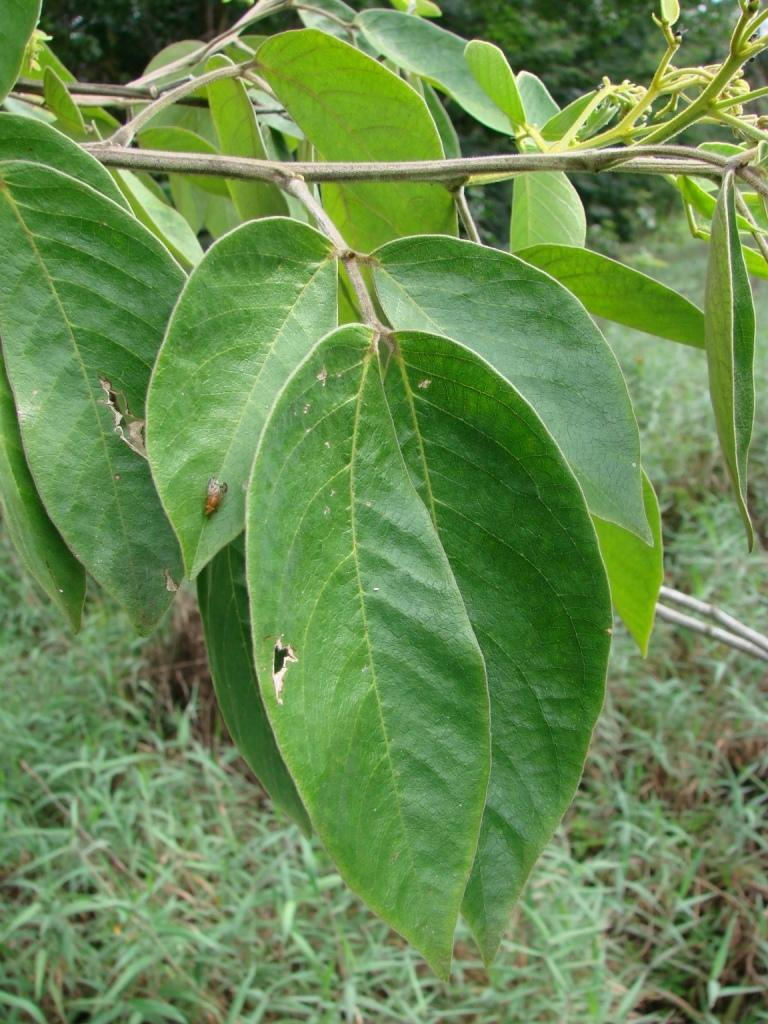What is visible in the foreground of the image? There are leaves in the foreground of the image. How are the leaves connected to each other? The leaves are attached to a stem. What can be seen in the background of the image? The background of the image appears to be trees and grassland. Where is the market located in the image? There is no market present in the image. Can you see an airplane flying in the sky in the image? There is no airplane visible in the image. 